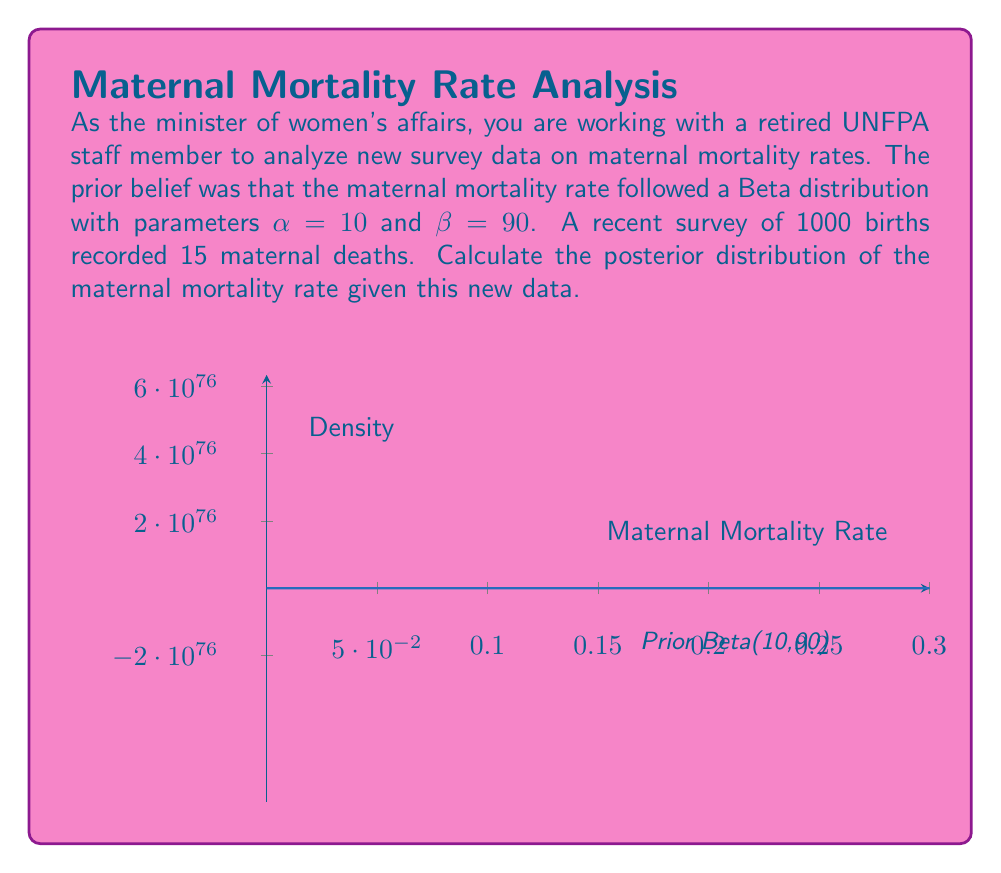Give your solution to this math problem. To solve this problem, we'll use Bayesian inference with a Beta-Binomial model:

1) The prior distribution is Beta($\alpha, \beta$) with $\alpha=10$ and $\beta=90$.

2) The likelihood of the data is Binomial(n, θ), where n = 1000 (total births) and we observed x = 15 deaths.

3) The posterior distribution will also be a Beta distribution due to conjugacy.

4) The formula for updating the Beta parameters is:
   $\alpha_{posterior} = \alpha_{prior} + x$
   $\beta_{posterior} = \beta_{prior} + (n - x)$

5) Substituting our values:
   $\alpha_{posterior} = 10 + 15 = 25$
   $\beta_{posterior} = 90 + (1000 - 15) = 1075$

Therefore, the posterior distribution is Beta(25, 1075).

The mean of this distribution (an estimate of the maternal mortality rate) is:
$$\frac{\alpha_{posterior}}{\alpha_{posterior} + \beta_{posterior}} = \frac{25}{25 + 1075} \approx 0.0227$$

This indicates a maternal mortality rate of about 2.27%, which is lower than the prior mean of $\frac{10}{10+90} \approx 0.1$ or 10%.
Answer: Beta(25, 1075) 